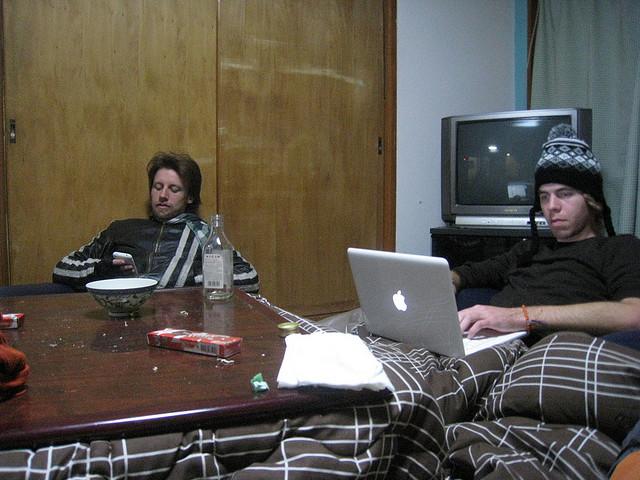What is one of the guys doing in  bed?
Answer briefly. On computer. How many people are facing the camera?
Short answer required. 2. Are they related?
Keep it brief. Yes. What gaming system are the people playing?
Keep it brief. Computer. What make is the laptop?
Quick response, please. Apple. Is one of the guys asleep?
Short answer required. No. 